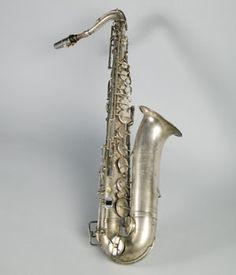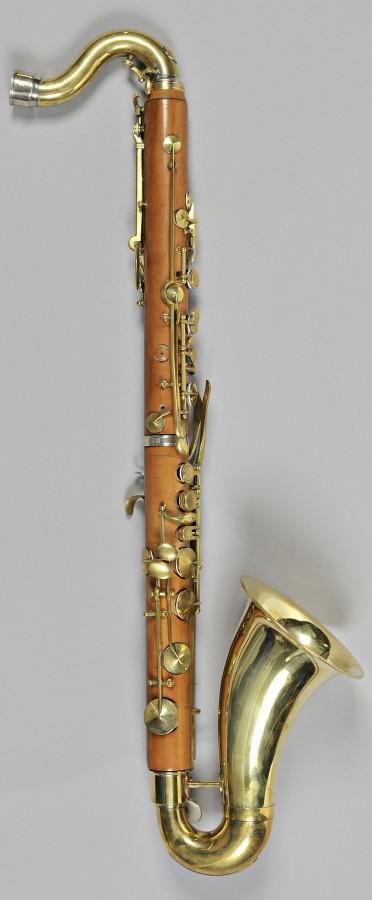The first image is the image on the left, the second image is the image on the right. Assess this claim about the two images: "The saxophone in one of the images is against a solid white background.". Correct or not? Answer yes or no. No. 